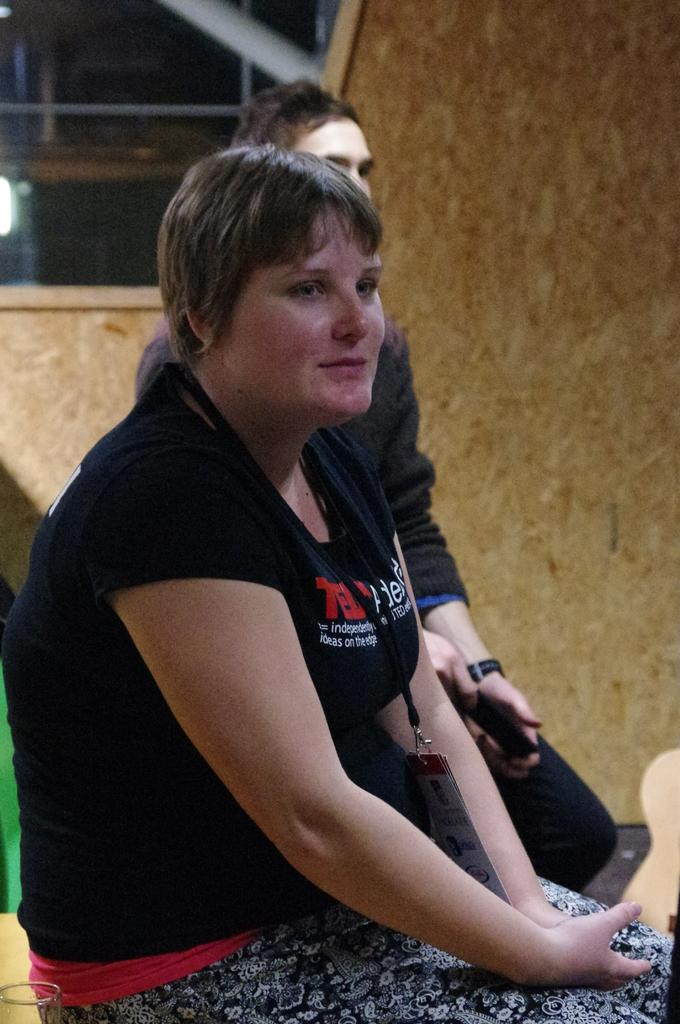How many people are present in the image? There are two persons in the image. What is visible in the background of the image? There is a wall in the background of the image. Can you describe the lighting conditions in the image? There is light visible in the image. What type of zebra can be seen in the image? There is no zebra present in the image. What message of hope can be read from the image? The image does not contain any text or message, so it cannot convey a message of hope. 